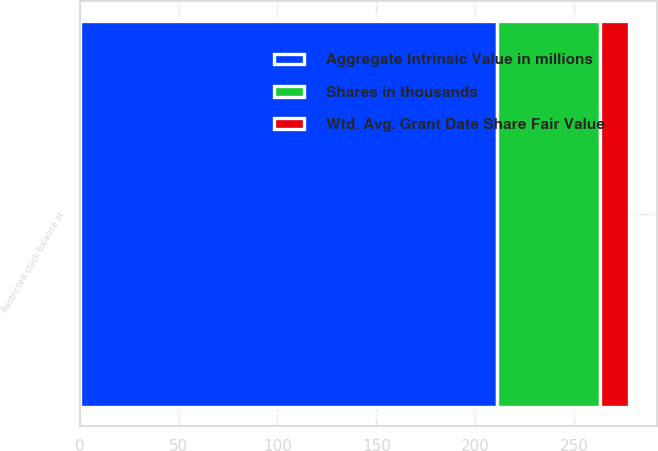Convert chart. <chart><loc_0><loc_0><loc_500><loc_500><stacked_bar_chart><ecel><fcel>Restricted stock balance at<nl><fcel>Aggregate Intrinsic Value in millions<fcel>211<nl><fcel>Shares in thousands<fcel>52.05<nl><fcel>Wtd. Avg. Grant Date Share Fair Value<fcel>14.7<nl></chart> 